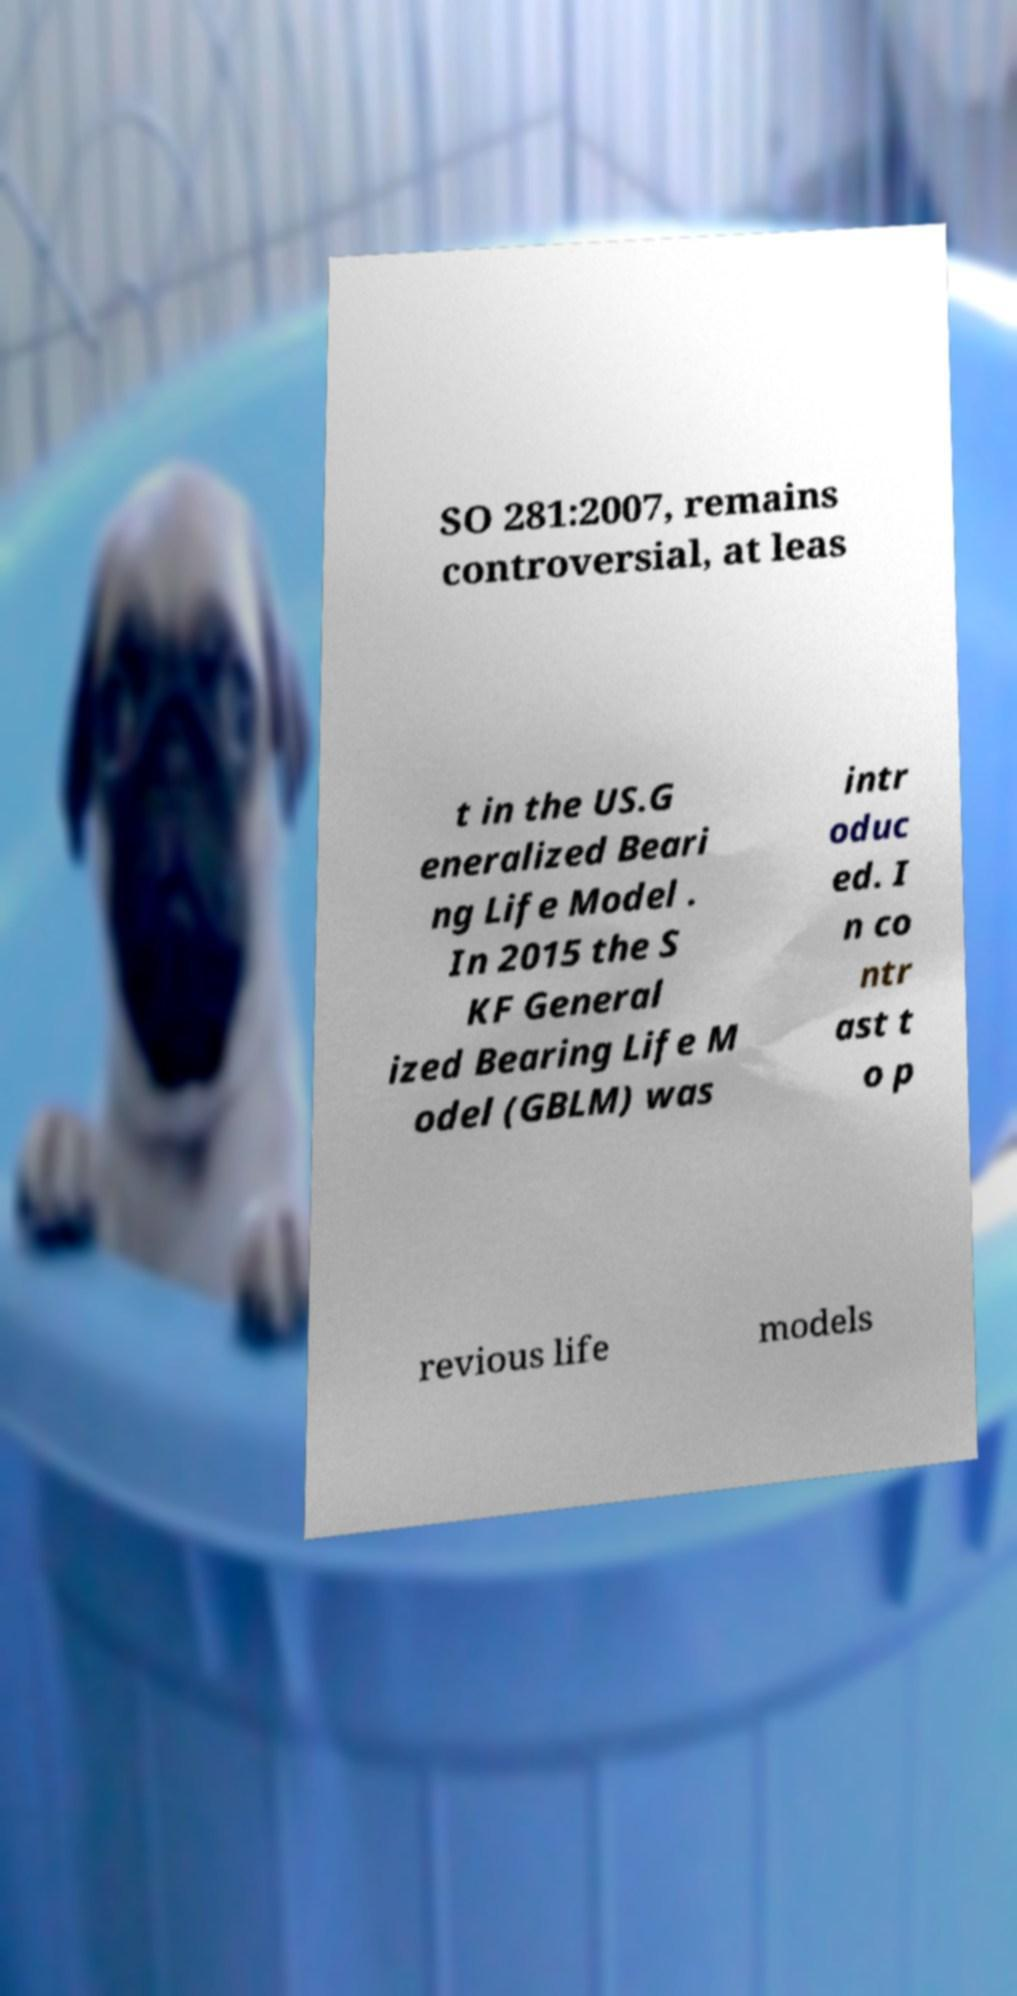Can you read and provide the text displayed in the image?This photo seems to have some interesting text. Can you extract and type it out for me? SO 281:2007, remains controversial, at leas t in the US.G eneralized Beari ng Life Model . In 2015 the S KF General ized Bearing Life M odel (GBLM) was intr oduc ed. I n co ntr ast t o p revious life models 